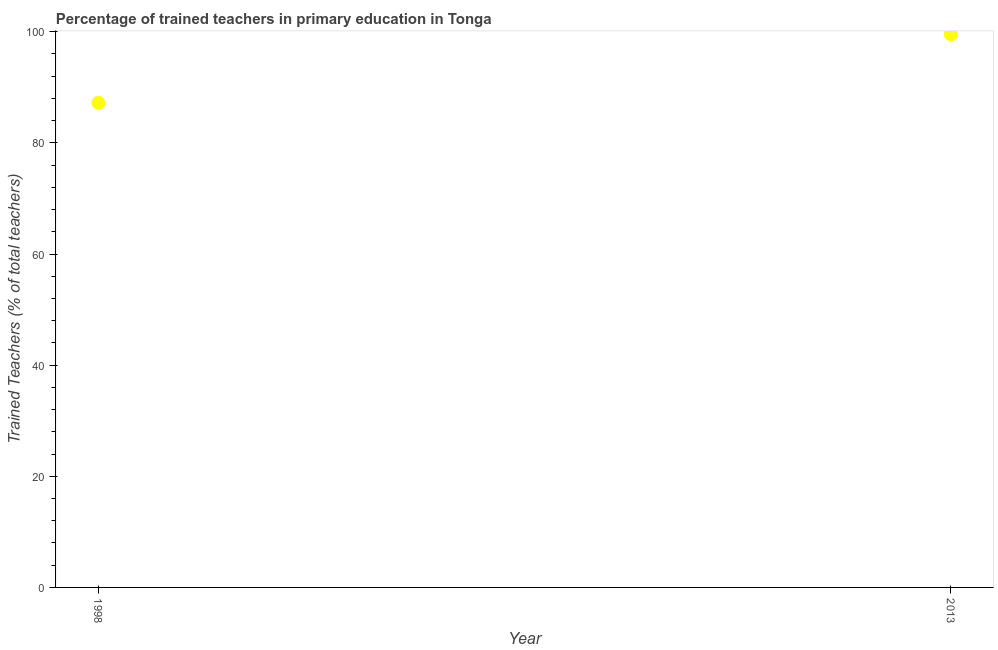What is the percentage of trained teachers in 1998?
Your answer should be very brief. 87.23. Across all years, what is the maximum percentage of trained teachers?
Offer a very short reply. 99.55. Across all years, what is the minimum percentage of trained teachers?
Provide a succinct answer. 87.23. In which year was the percentage of trained teachers maximum?
Make the answer very short. 2013. In which year was the percentage of trained teachers minimum?
Your response must be concise. 1998. What is the sum of the percentage of trained teachers?
Offer a very short reply. 186.79. What is the difference between the percentage of trained teachers in 1998 and 2013?
Your answer should be very brief. -12.32. What is the average percentage of trained teachers per year?
Your response must be concise. 93.39. What is the median percentage of trained teachers?
Provide a succinct answer. 93.39. What is the ratio of the percentage of trained teachers in 1998 to that in 2013?
Provide a short and direct response. 0.88. Is the percentage of trained teachers in 1998 less than that in 2013?
Give a very brief answer. Yes. How many dotlines are there?
Provide a short and direct response. 1. How many years are there in the graph?
Your answer should be compact. 2. What is the difference between two consecutive major ticks on the Y-axis?
Your answer should be very brief. 20. Does the graph contain any zero values?
Offer a terse response. No. Does the graph contain grids?
Your response must be concise. No. What is the title of the graph?
Provide a succinct answer. Percentage of trained teachers in primary education in Tonga. What is the label or title of the X-axis?
Provide a succinct answer. Year. What is the label or title of the Y-axis?
Your answer should be compact. Trained Teachers (% of total teachers). What is the Trained Teachers (% of total teachers) in 1998?
Ensure brevity in your answer.  87.23. What is the Trained Teachers (% of total teachers) in 2013?
Offer a terse response. 99.55. What is the difference between the Trained Teachers (% of total teachers) in 1998 and 2013?
Your answer should be very brief. -12.32. What is the ratio of the Trained Teachers (% of total teachers) in 1998 to that in 2013?
Give a very brief answer. 0.88. 